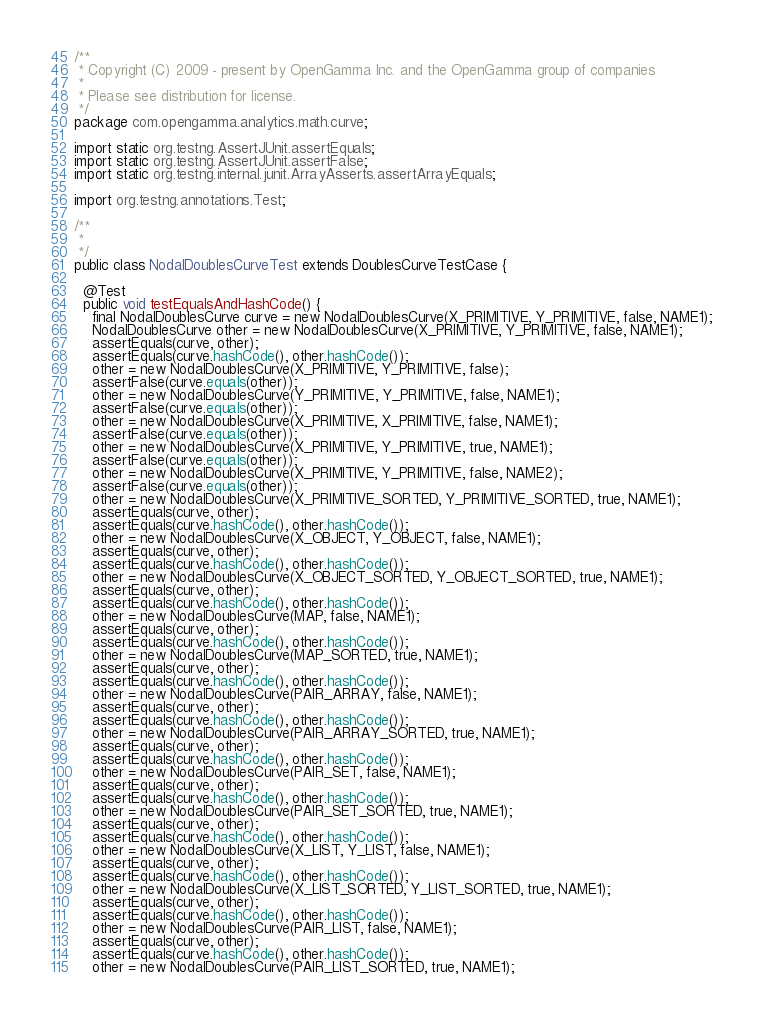<code> <loc_0><loc_0><loc_500><loc_500><_Java_>/**
 * Copyright (C) 2009 - present by OpenGamma Inc. and the OpenGamma group of companies
 * 
 * Please see distribution for license.
 */
package com.opengamma.analytics.math.curve;

import static org.testng.AssertJUnit.assertEquals;
import static org.testng.AssertJUnit.assertFalse;
import static org.testng.internal.junit.ArrayAsserts.assertArrayEquals;

import org.testng.annotations.Test;

/**
 * 
 */
public class NodalDoublesCurveTest extends DoublesCurveTestCase {

  @Test
  public void testEqualsAndHashCode() {
    final NodalDoublesCurve curve = new NodalDoublesCurve(X_PRIMITIVE, Y_PRIMITIVE, false, NAME1);
    NodalDoublesCurve other = new NodalDoublesCurve(X_PRIMITIVE, Y_PRIMITIVE, false, NAME1);
    assertEquals(curve, other);
    assertEquals(curve.hashCode(), other.hashCode());
    other = new NodalDoublesCurve(X_PRIMITIVE, Y_PRIMITIVE, false);
    assertFalse(curve.equals(other));
    other = new NodalDoublesCurve(Y_PRIMITIVE, Y_PRIMITIVE, false, NAME1);
    assertFalse(curve.equals(other));
    other = new NodalDoublesCurve(X_PRIMITIVE, X_PRIMITIVE, false, NAME1);
    assertFalse(curve.equals(other));
    other = new NodalDoublesCurve(X_PRIMITIVE, Y_PRIMITIVE, true, NAME1);
    assertFalse(curve.equals(other));
    other = new NodalDoublesCurve(X_PRIMITIVE, Y_PRIMITIVE, false, NAME2);
    assertFalse(curve.equals(other));
    other = new NodalDoublesCurve(X_PRIMITIVE_SORTED, Y_PRIMITIVE_SORTED, true, NAME1);
    assertEquals(curve, other);
    assertEquals(curve.hashCode(), other.hashCode());
    other = new NodalDoublesCurve(X_OBJECT, Y_OBJECT, false, NAME1);
    assertEquals(curve, other);
    assertEquals(curve.hashCode(), other.hashCode());
    other = new NodalDoublesCurve(X_OBJECT_SORTED, Y_OBJECT_SORTED, true, NAME1);
    assertEquals(curve, other);
    assertEquals(curve.hashCode(), other.hashCode());
    other = new NodalDoublesCurve(MAP, false, NAME1);
    assertEquals(curve, other);
    assertEquals(curve.hashCode(), other.hashCode());
    other = new NodalDoublesCurve(MAP_SORTED, true, NAME1);
    assertEquals(curve, other);
    assertEquals(curve.hashCode(), other.hashCode());
    other = new NodalDoublesCurve(PAIR_ARRAY, false, NAME1);
    assertEquals(curve, other);
    assertEquals(curve.hashCode(), other.hashCode());
    other = new NodalDoublesCurve(PAIR_ARRAY_SORTED, true, NAME1);
    assertEquals(curve, other);
    assertEquals(curve.hashCode(), other.hashCode());
    other = new NodalDoublesCurve(PAIR_SET, false, NAME1);
    assertEquals(curve, other);
    assertEquals(curve.hashCode(), other.hashCode());
    other = new NodalDoublesCurve(PAIR_SET_SORTED, true, NAME1);
    assertEquals(curve, other);
    assertEquals(curve.hashCode(), other.hashCode());
    other = new NodalDoublesCurve(X_LIST, Y_LIST, false, NAME1);
    assertEquals(curve, other);
    assertEquals(curve.hashCode(), other.hashCode());
    other = new NodalDoublesCurve(X_LIST_SORTED, Y_LIST_SORTED, true, NAME1);
    assertEquals(curve, other);
    assertEquals(curve.hashCode(), other.hashCode());
    other = new NodalDoublesCurve(PAIR_LIST, false, NAME1);
    assertEquals(curve, other);
    assertEquals(curve.hashCode(), other.hashCode());
    other = new NodalDoublesCurve(PAIR_LIST_SORTED, true, NAME1);</code> 